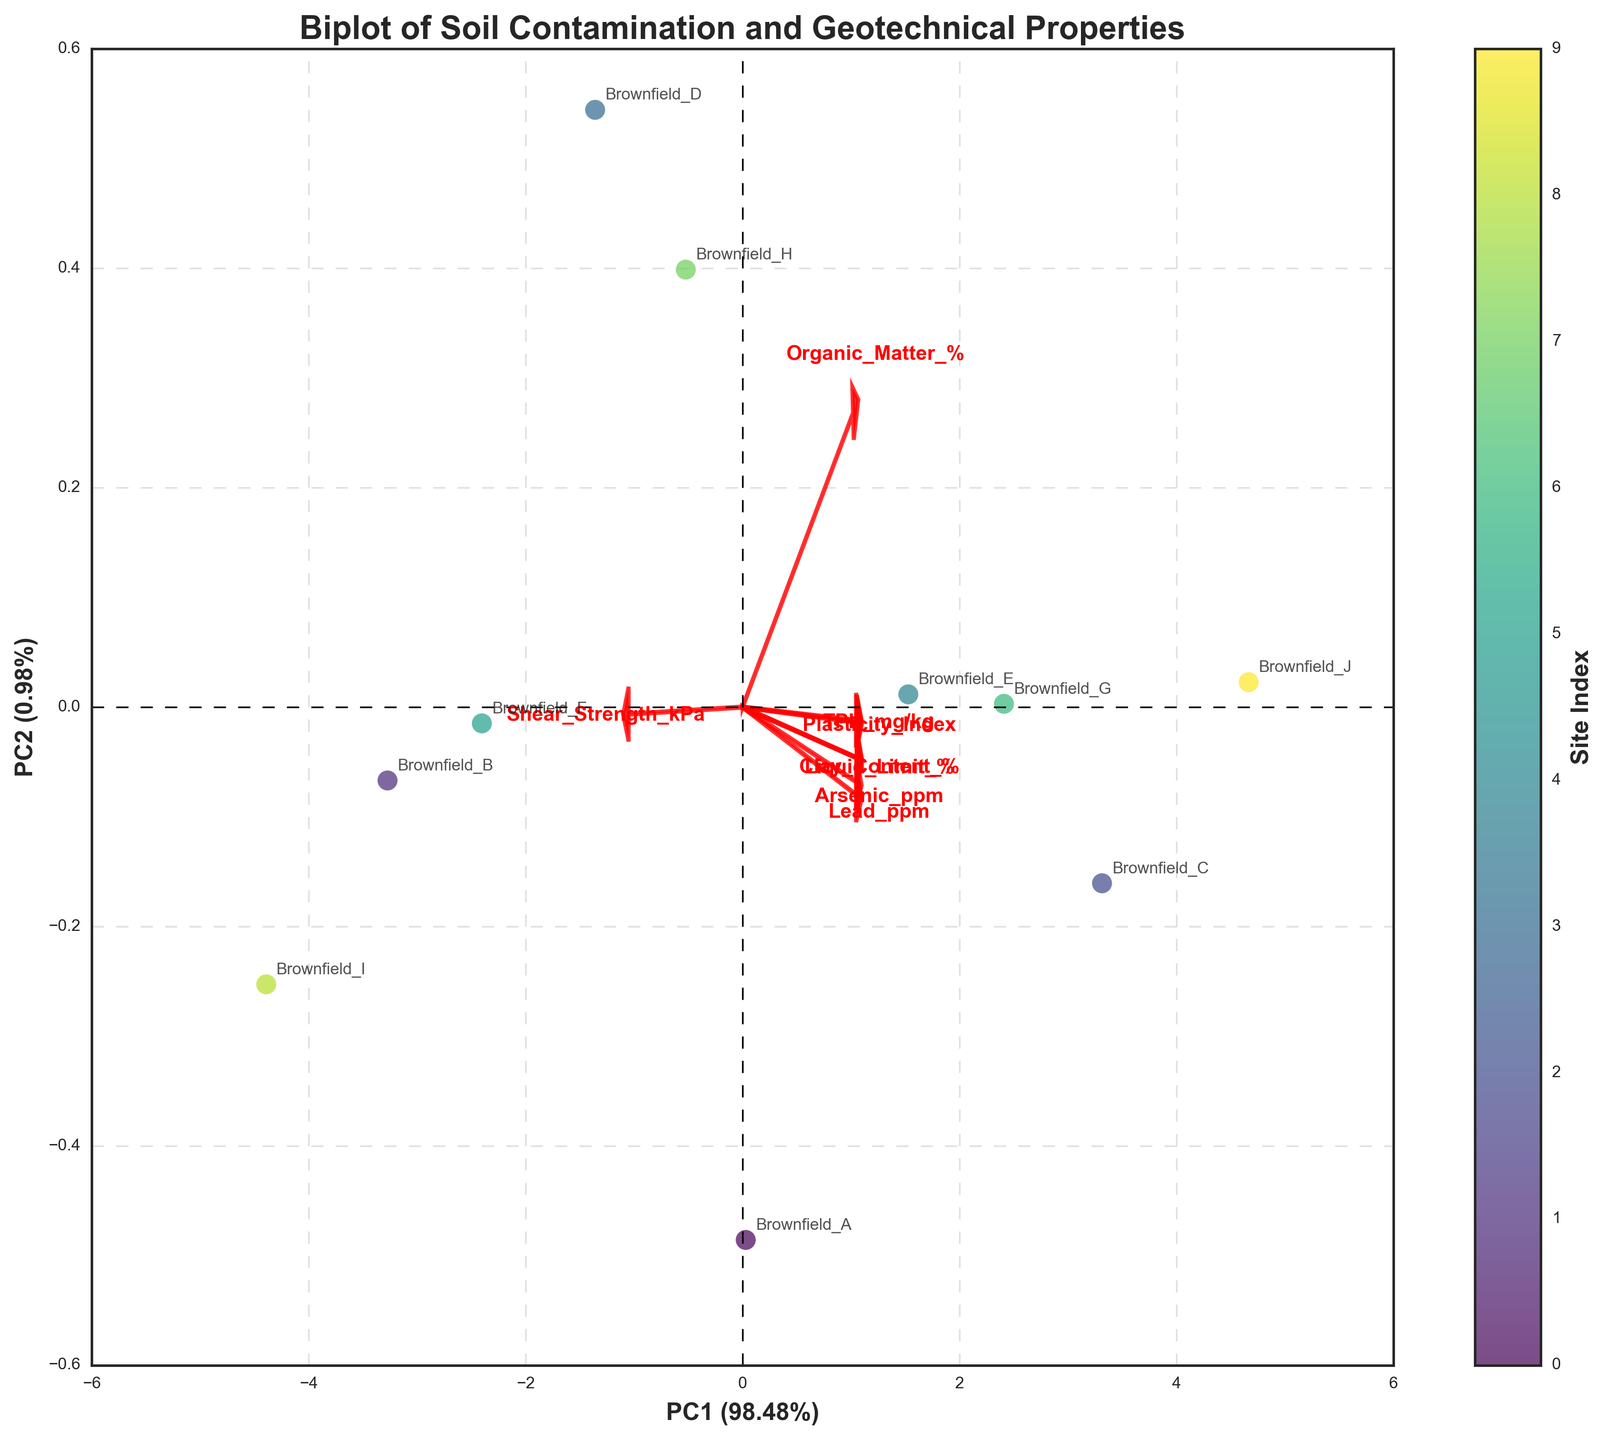What is the title of the biplot? The title of the plot is displayed at the top of the figure, usually in a bold and larger font compared to other text elements. It gives a succinct description of what the plot represents.
Answer: Biplot of Soil Contamination and Geotechnical Properties How many data points are shown in the plot? Each data point represents a soil sample from a brownfield site, typically marked by a dot or some other symbol. By counting these symbols, you can determine the number of data points.
Answer: 10 Which site has the highest value on PC1? Examine the positions of the data points along the x-axis (PC1). The site with the highest value on PC1 will be the one furthest to the right.
Answer: Brownfield_J Which direction do the loading vectors of "Lead_ppm" and "TPH_mg/kg" point? Loadings are represented by arrows originating from the origin. By observing the direction in which the arrows for "Lead_ppm" and "TPH_mg/kg" extend, you can interpret their respective directions.
Answer: Right and slightly up for both Is the "Shear_Strength_kPa" variable more correlated with PC1 or PC2? To determine the correlation, observe the length and direction of the "Shear_Strength_kPa" loading vector along the PC1 and PC2 axes. The longer it extends along an axis, the more it correlates with that principal component.
Answer: PC2 Which variables have strong positive correlations with each other? Variables that point in similar directions and have similar lengths signify strong positive correlations. Examine the angles between the loading vectors; smaller angles (close to zero degrees) indicate strong positive correlations.
Answer: Lead_ppm and TPH_mg/kg Are "Organic_Matter_%" and "Clay_Content_%" positively or negatively correlated? Check the angles between the loading vectors of "Organic_Matter_%" and "Clay_Content_%". If they point in roughly the same direction, they are positively correlated; if they point in opposite directions, they are negatively correlated.
Answer: Positively correlated How much variance do PC1 and PC2 explain together? The explained variance for each principal component is usually reflected in the axis labels as percentages. Sum the explained variance percentages for PC1 and PC2.
Answer: Approximately 62% Which site has the lowest value on PC2? Identify the data point with the smallest value along the y-axis (PC2). This site's label will be the answer.
Answer: Brownfield_I 